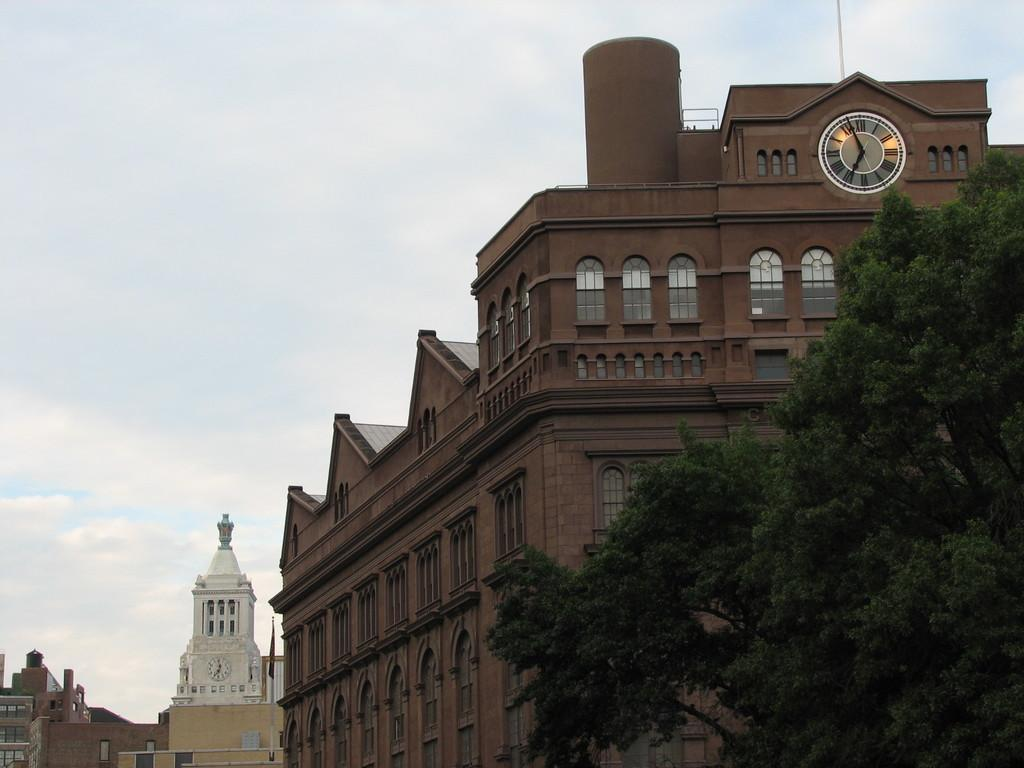What type of structures can be seen in the image? There are buildings in the image. What other natural elements are present in the image? There are trees in the image. What part of the natural environment is visible in the image? The sky is visible in the image. What can be observed in the sky? Clouds are present in the sky. What grade did the shelf receive for its performance in the image? There is no shelf present in the image, and therefore no grade can be assigned. 